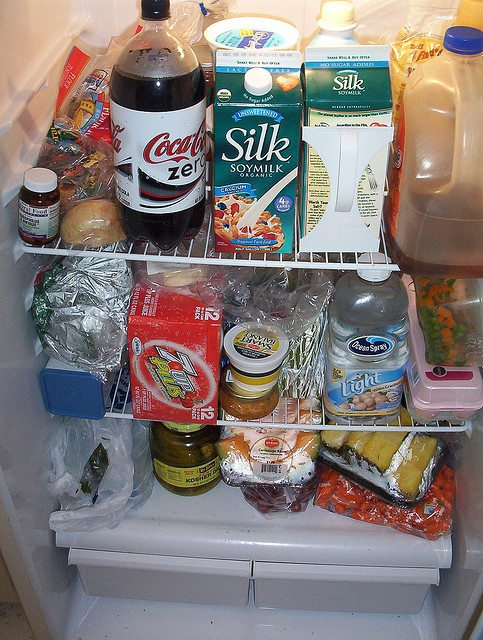Describe the objects in this image and their specific colors. I can see refrigerator in gray, darkgray, lightgray, and black tones, bottle in tan, brown, and gray tones, bottle in tan, black, lightblue, darkgray, and gray tones, bottle in tan, gray, and darkgray tones, and bottle in tan, black, olive, and gray tones in this image. 